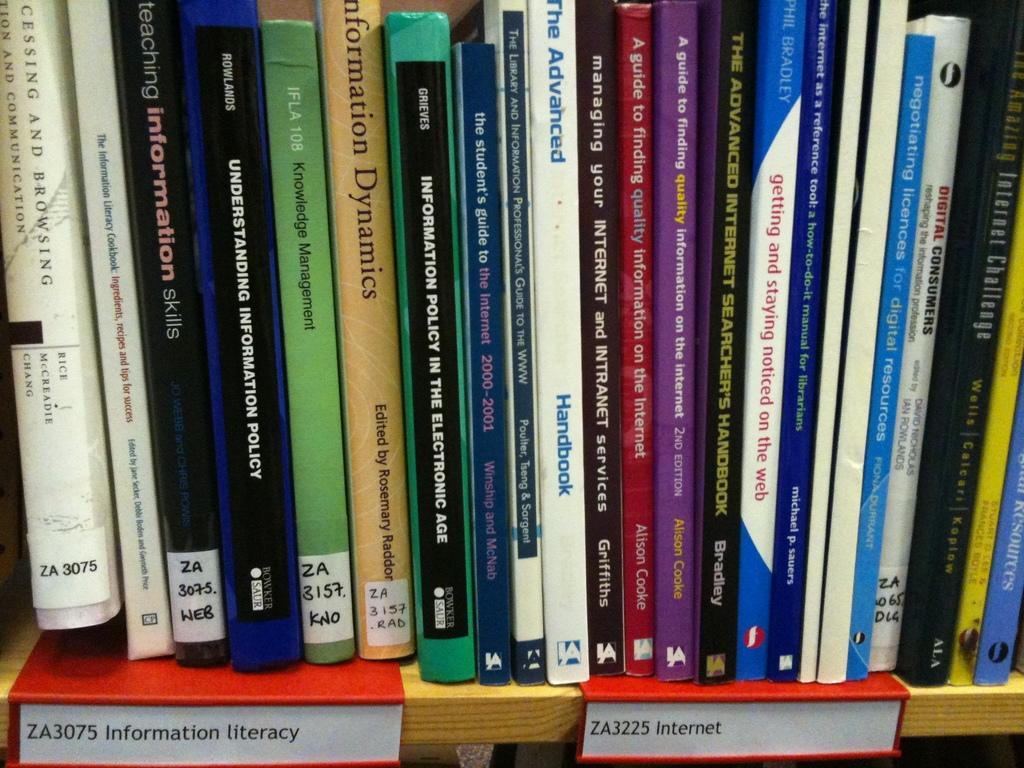Can you describe this image briefly? The picture consists of books in a bookshelf. At the bottom there are name plates. 